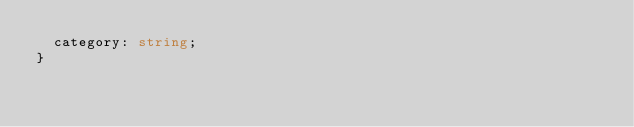<code> <loc_0><loc_0><loc_500><loc_500><_TypeScript_>  category: string;
}
</code> 